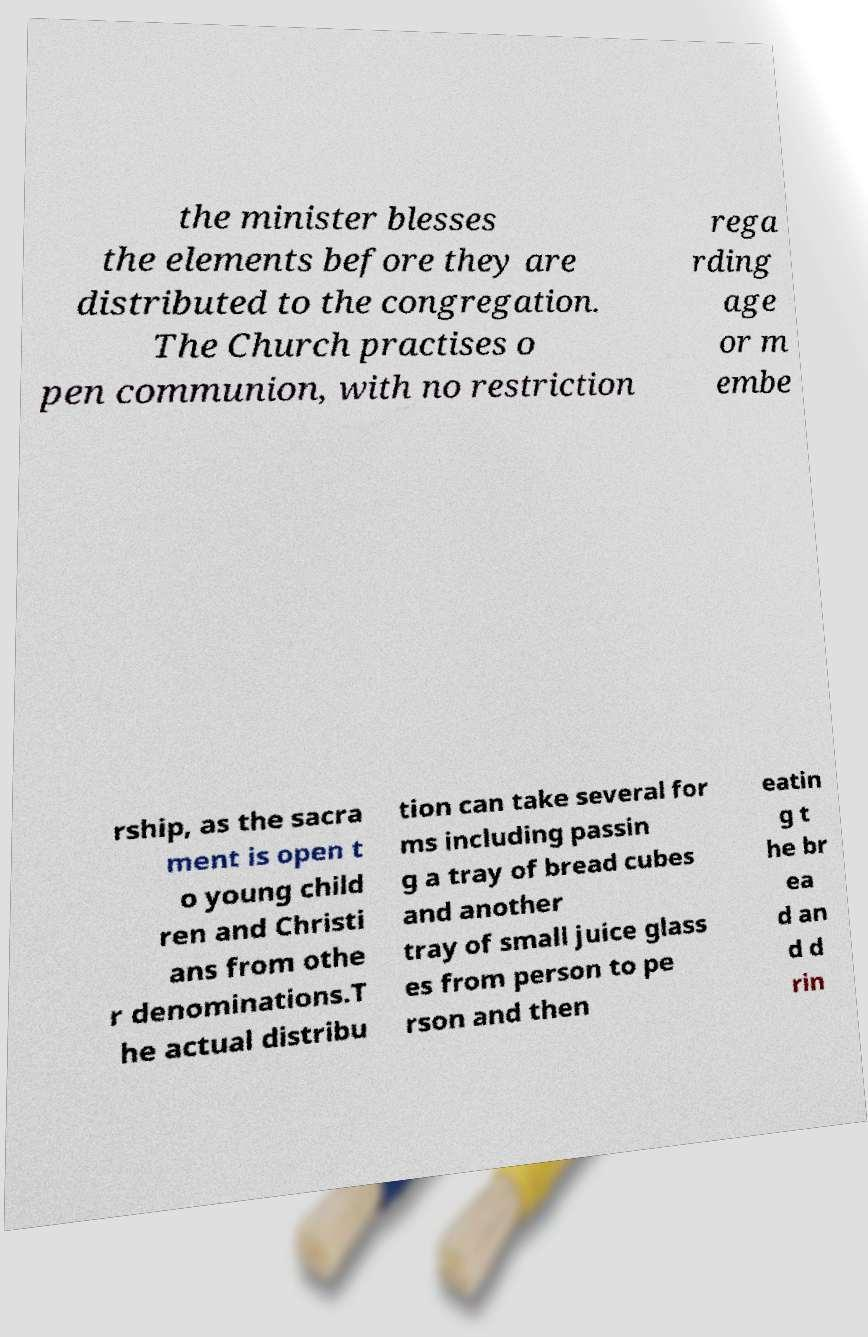Could you assist in decoding the text presented in this image and type it out clearly? the minister blesses the elements before they are distributed to the congregation. The Church practises o pen communion, with no restriction rega rding age or m embe rship, as the sacra ment is open t o young child ren and Christi ans from othe r denominations.T he actual distribu tion can take several for ms including passin g a tray of bread cubes and another tray of small juice glass es from person to pe rson and then eatin g t he br ea d an d d rin 